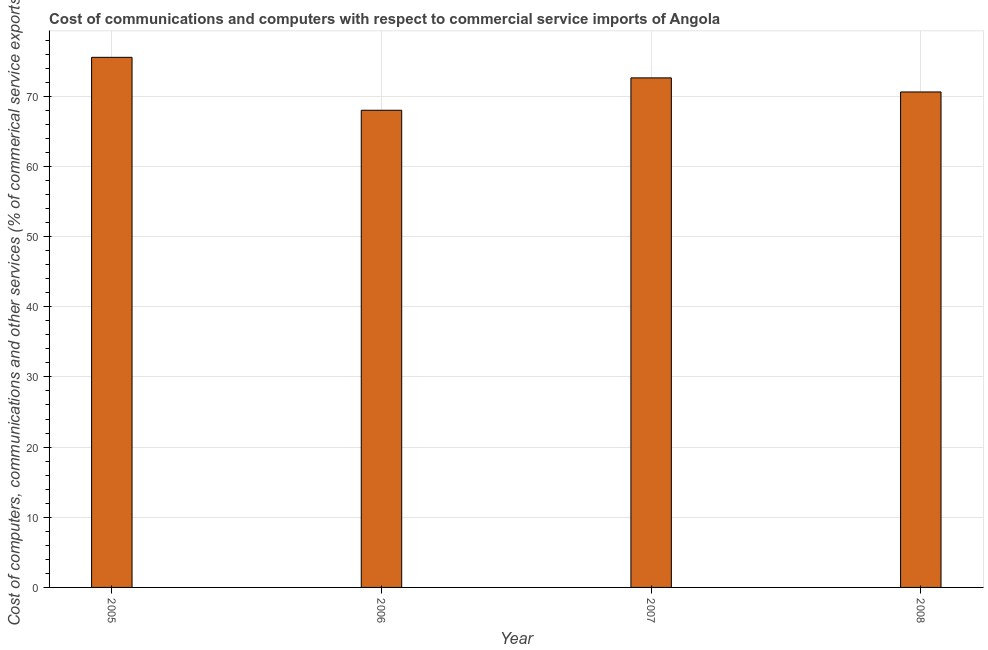Does the graph contain any zero values?
Your answer should be very brief. No. What is the title of the graph?
Your response must be concise. Cost of communications and computers with respect to commercial service imports of Angola. What is the label or title of the X-axis?
Provide a succinct answer. Year. What is the label or title of the Y-axis?
Offer a terse response. Cost of computers, communications and other services (% of commerical service exports). What is the cost of communications in 2008?
Make the answer very short. 70.61. Across all years, what is the maximum  computer and other services?
Provide a short and direct response. 75.55. Across all years, what is the minimum cost of communications?
Give a very brief answer. 68.01. In which year was the cost of communications maximum?
Offer a very short reply. 2005. In which year was the cost of communications minimum?
Your response must be concise. 2006. What is the sum of the  computer and other services?
Keep it short and to the point. 286.78. What is the difference between the cost of communications in 2006 and 2007?
Offer a terse response. -4.61. What is the average cost of communications per year?
Provide a short and direct response. 71.7. What is the median  computer and other services?
Your answer should be compact. 71.62. Do a majority of the years between 2007 and 2005 (inclusive) have cost of communications greater than 38 %?
Your answer should be compact. Yes. What is the ratio of the cost of communications in 2007 to that in 2008?
Provide a short and direct response. 1.03. Is the  computer and other services in 2006 less than that in 2007?
Your answer should be very brief. Yes. What is the difference between the highest and the second highest  computer and other services?
Your response must be concise. 2.93. What is the difference between the highest and the lowest cost of communications?
Your answer should be compact. 7.54. How many bars are there?
Give a very brief answer. 4. How many years are there in the graph?
Ensure brevity in your answer.  4. What is the difference between two consecutive major ticks on the Y-axis?
Offer a terse response. 10. What is the Cost of computers, communications and other services (% of commerical service exports) of 2005?
Give a very brief answer. 75.55. What is the Cost of computers, communications and other services (% of commerical service exports) in 2006?
Offer a terse response. 68.01. What is the Cost of computers, communications and other services (% of commerical service exports) in 2007?
Your response must be concise. 72.62. What is the Cost of computers, communications and other services (% of commerical service exports) in 2008?
Your response must be concise. 70.61. What is the difference between the Cost of computers, communications and other services (% of commerical service exports) in 2005 and 2006?
Make the answer very short. 7.54. What is the difference between the Cost of computers, communications and other services (% of commerical service exports) in 2005 and 2007?
Offer a very short reply. 2.93. What is the difference between the Cost of computers, communications and other services (% of commerical service exports) in 2005 and 2008?
Your answer should be compact. 4.94. What is the difference between the Cost of computers, communications and other services (% of commerical service exports) in 2006 and 2007?
Your response must be concise. -4.61. What is the difference between the Cost of computers, communications and other services (% of commerical service exports) in 2006 and 2008?
Offer a very short reply. -2.61. What is the difference between the Cost of computers, communications and other services (% of commerical service exports) in 2007 and 2008?
Your response must be concise. 2.01. What is the ratio of the Cost of computers, communications and other services (% of commerical service exports) in 2005 to that in 2006?
Your answer should be compact. 1.11. What is the ratio of the Cost of computers, communications and other services (% of commerical service exports) in 2005 to that in 2007?
Offer a very short reply. 1.04. What is the ratio of the Cost of computers, communications and other services (% of commerical service exports) in 2005 to that in 2008?
Provide a succinct answer. 1.07. What is the ratio of the Cost of computers, communications and other services (% of commerical service exports) in 2006 to that in 2007?
Your answer should be very brief. 0.94. What is the ratio of the Cost of computers, communications and other services (% of commerical service exports) in 2006 to that in 2008?
Your answer should be very brief. 0.96. What is the ratio of the Cost of computers, communications and other services (% of commerical service exports) in 2007 to that in 2008?
Give a very brief answer. 1.03. 